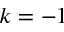Convert formula to latex. <formula><loc_0><loc_0><loc_500><loc_500>k = - 1</formula> 